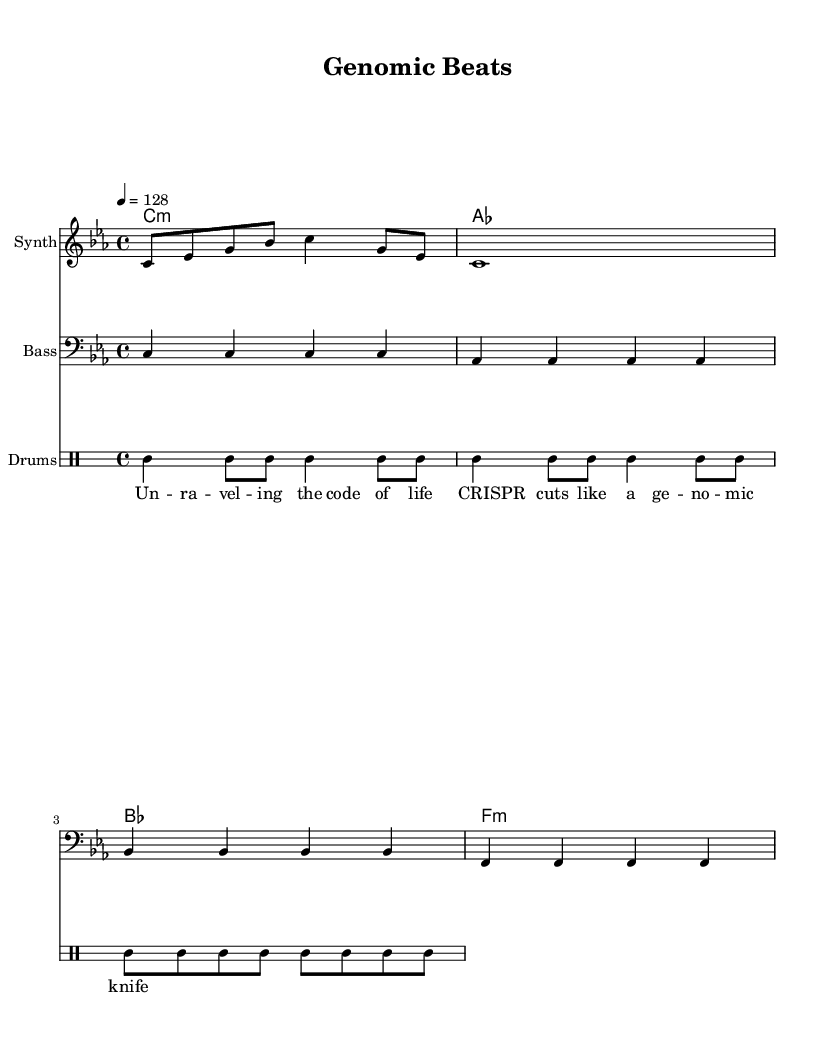What is the key signature of this music? The key signature indicates the use of C minor, which has three flats (B♭, E♭, A♭). Looking at the global section of the code, we see it explicitly states \key c \minor.
Answer: C minor What is the time signature of this music? The time signature is found in the global section of the code, listed as \time 4/4, which means there are four beats in each measure and each beat is a quarter note.
Answer: 4/4 What is the tempo marking for this piece? The tempo marking is given in the global section as \tempo 4 = 128, indicating a speed of 128 beats per minute, which is common for upbeat electronic music like House.
Answer: 128 How many measures are present in the melody? Counting the bars in the melody section, we find the number of measures; here, there are two measures in the melody (one finishes with a quarter note and one with a whole note).
Answer: 2 What type of drum style is used in this piece? The drum style is indicated in the DrumStaff section that mentions drumStyleTable = #percussion-style, which typically refers to standard electronic drum patterns often found in House music.
Answer: Percussion What are the first two lyrics of the song? The lyrics are shown in the new Lyrics section, where the first two phrases are "Un - ra - vel - ing the code of life" and "CRIS - PR cuts like a ge - no - mic knife".
Answer: Un - ra - vel - ing the code of life How many different chord types are there in the harmony? The harmony section reveals four chord sequences; specifically, C minor, A♭ major, B♭ major, and F minor. These indicate that four different chord types are indeed present when we analyze the harmony line.
Answer: 4 